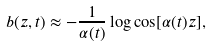<formula> <loc_0><loc_0><loc_500><loc_500>b ( z , t ) \approx - \frac { 1 } { \alpha ( t ) } \log \cos [ \alpha ( t ) z ] ,</formula> 